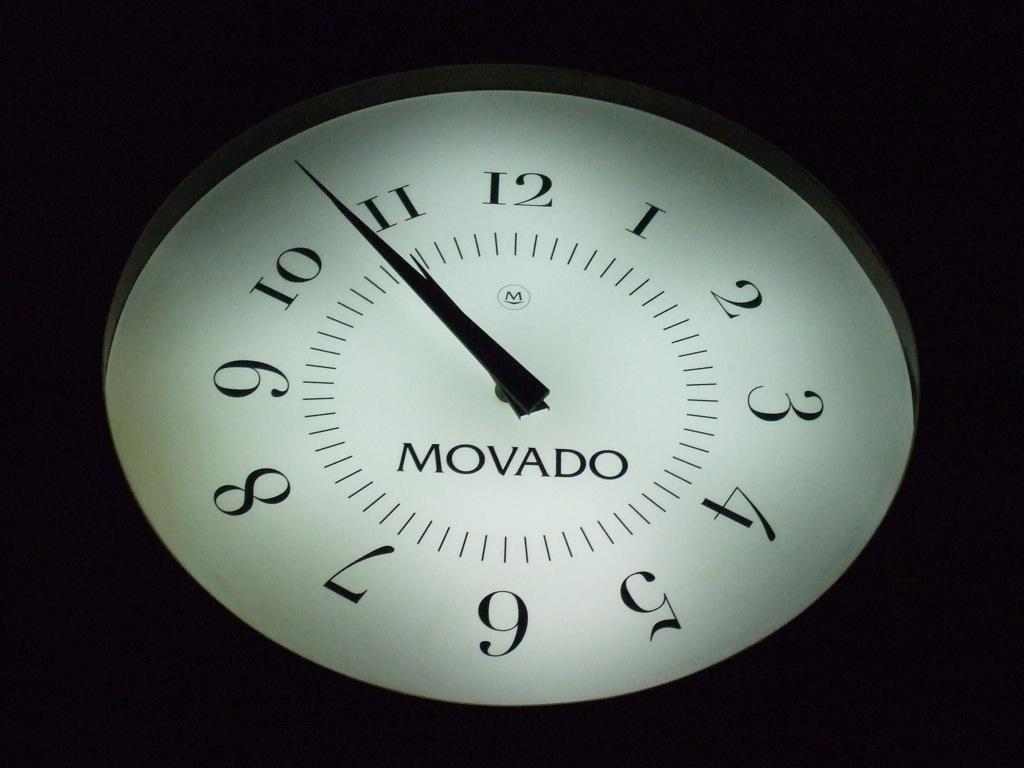<image>
Describe the image concisely. Movado black and white clock with one to 12 timer on it 